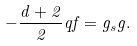Convert formula to latex. <formula><loc_0><loc_0><loc_500><loc_500>- \frac { d + 2 } { 2 } q f = g _ { s } g .</formula> 